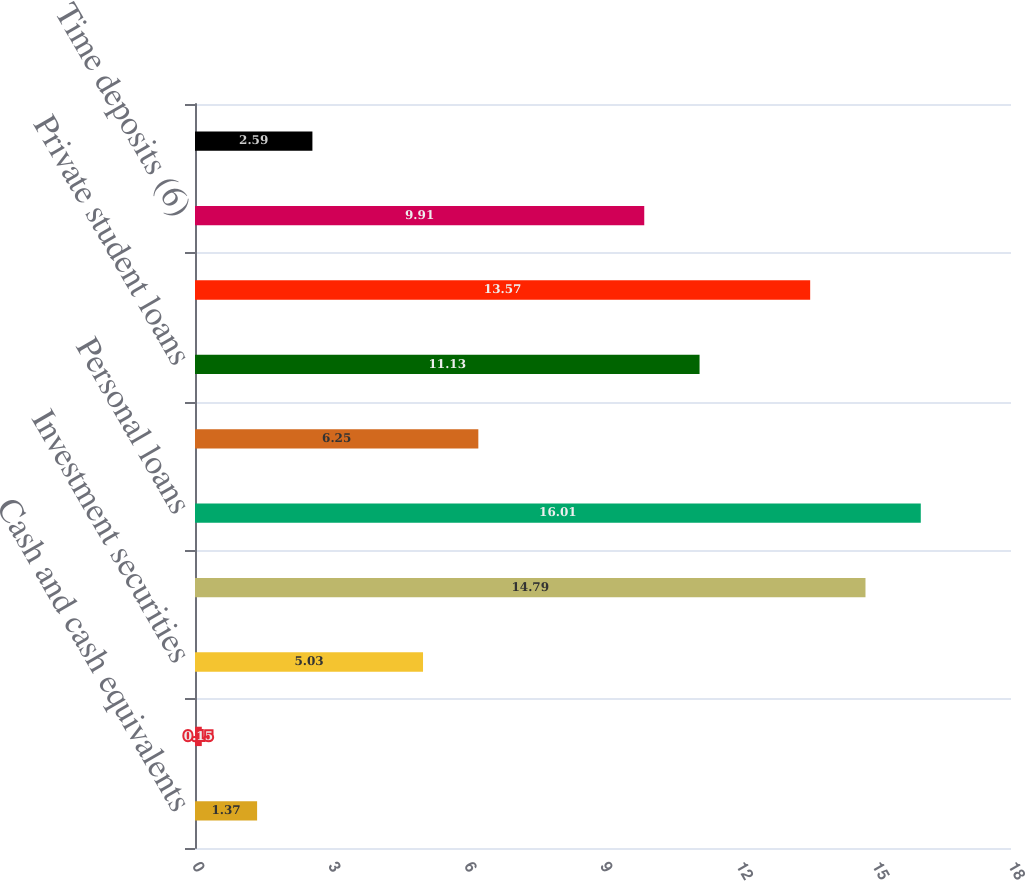Convert chart. <chart><loc_0><loc_0><loc_500><loc_500><bar_chart><fcel>Cash and cash equivalents<fcel>Restricted cash<fcel>Investment securities<fcel>Credit card (3)(4)<fcel>Personal loans<fcel>Federal student loans (5)<fcel>Private student loans<fcel>Other<fcel>Time deposits (6)<fcel>Money market deposits<nl><fcel>1.37<fcel>0.15<fcel>5.03<fcel>14.79<fcel>16.01<fcel>6.25<fcel>11.13<fcel>13.57<fcel>9.91<fcel>2.59<nl></chart> 